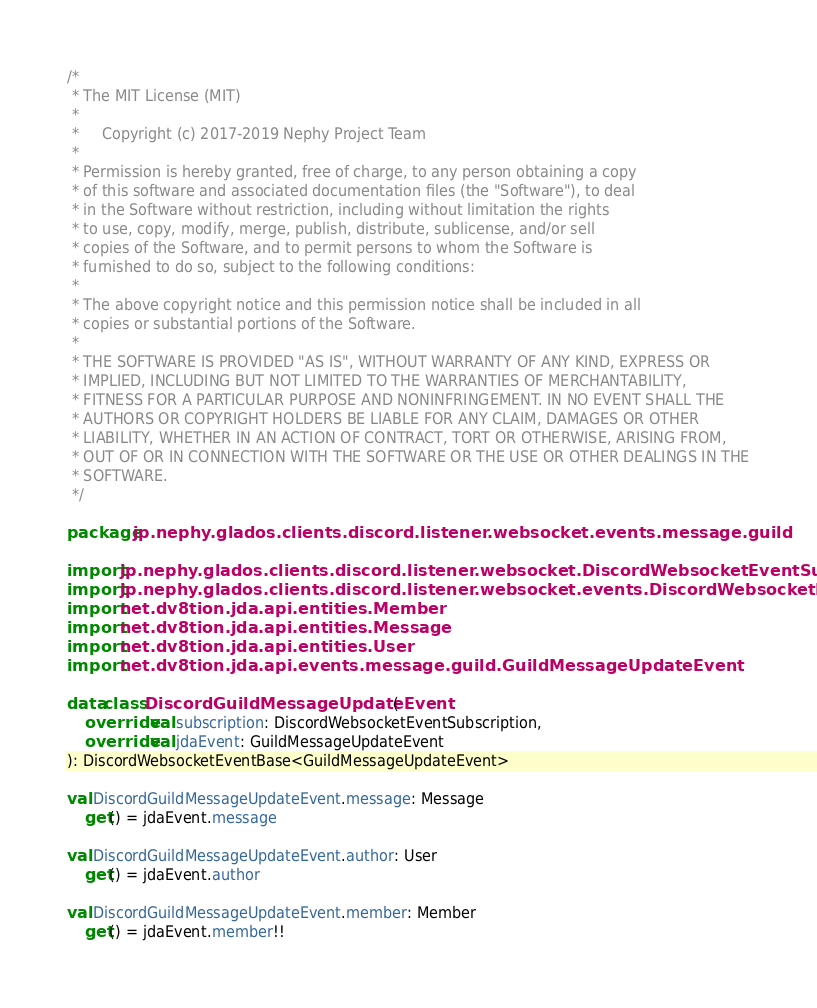Convert code to text. <code><loc_0><loc_0><loc_500><loc_500><_Kotlin_>/*
 * The MIT License (MIT)
 *
 *     Copyright (c) 2017-2019 Nephy Project Team
 *
 * Permission is hereby granted, free of charge, to any person obtaining a copy
 * of this software and associated documentation files (the "Software"), to deal
 * in the Software without restriction, including without limitation the rights
 * to use, copy, modify, merge, publish, distribute, sublicense, and/or sell
 * copies of the Software, and to permit persons to whom the Software is
 * furnished to do so, subject to the following conditions:
 *
 * The above copyright notice and this permission notice shall be included in all
 * copies or substantial portions of the Software.
 *
 * THE SOFTWARE IS PROVIDED "AS IS", WITHOUT WARRANTY OF ANY KIND, EXPRESS OR
 * IMPLIED, INCLUDING BUT NOT LIMITED TO THE WARRANTIES OF MERCHANTABILITY,
 * FITNESS FOR A PARTICULAR PURPOSE AND NONINFRINGEMENT. IN NO EVENT SHALL THE
 * AUTHORS OR COPYRIGHT HOLDERS BE LIABLE FOR ANY CLAIM, DAMAGES OR OTHER
 * LIABILITY, WHETHER IN AN ACTION OF CONTRACT, TORT OR OTHERWISE, ARISING FROM,
 * OUT OF OR IN CONNECTION WITH THE SOFTWARE OR THE USE OR OTHER DEALINGS IN THE
 * SOFTWARE.
 */

package jp.nephy.glados.clients.discord.listener.websocket.events.message.guild

import jp.nephy.glados.clients.discord.listener.websocket.DiscordWebsocketEventSubscription
import jp.nephy.glados.clients.discord.listener.websocket.events.DiscordWebsocketEventBase
import net.dv8tion.jda.api.entities.Member
import net.dv8tion.jda.api.entities.Message
import net.dv8tion.jda.api.entities.User
import net.dv8tion.jda.api.events.message.guild.GuildMessageUpdateEvent

data class DiscordGuildMessageUpdateEvent(
    override val subscription: DiscordWebsocketEventSubscription,
    override val jdaEvent: GuildMessageUpdateEvent
): DiscordWebsocketEventBase<GuildMessageUpdateEvent>

val DiscordGuildMessageUpdateEvent.message: Message
    get() = jdaEvent.message

val DiscordGuildMessageUpdateEvent.author: User
    get() = jdaEvent.author

val DiscordGuildMessageUpdateEvent.member: Member
    get() = jdaEvent.member!!
</code> 